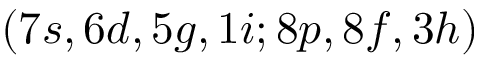<formula> <loc_0><loc_0><loc_500><loc_500>( 7 s , 6 d , 5 g , 1 i ; 8 p , 8 f , 3 h )</formula> 